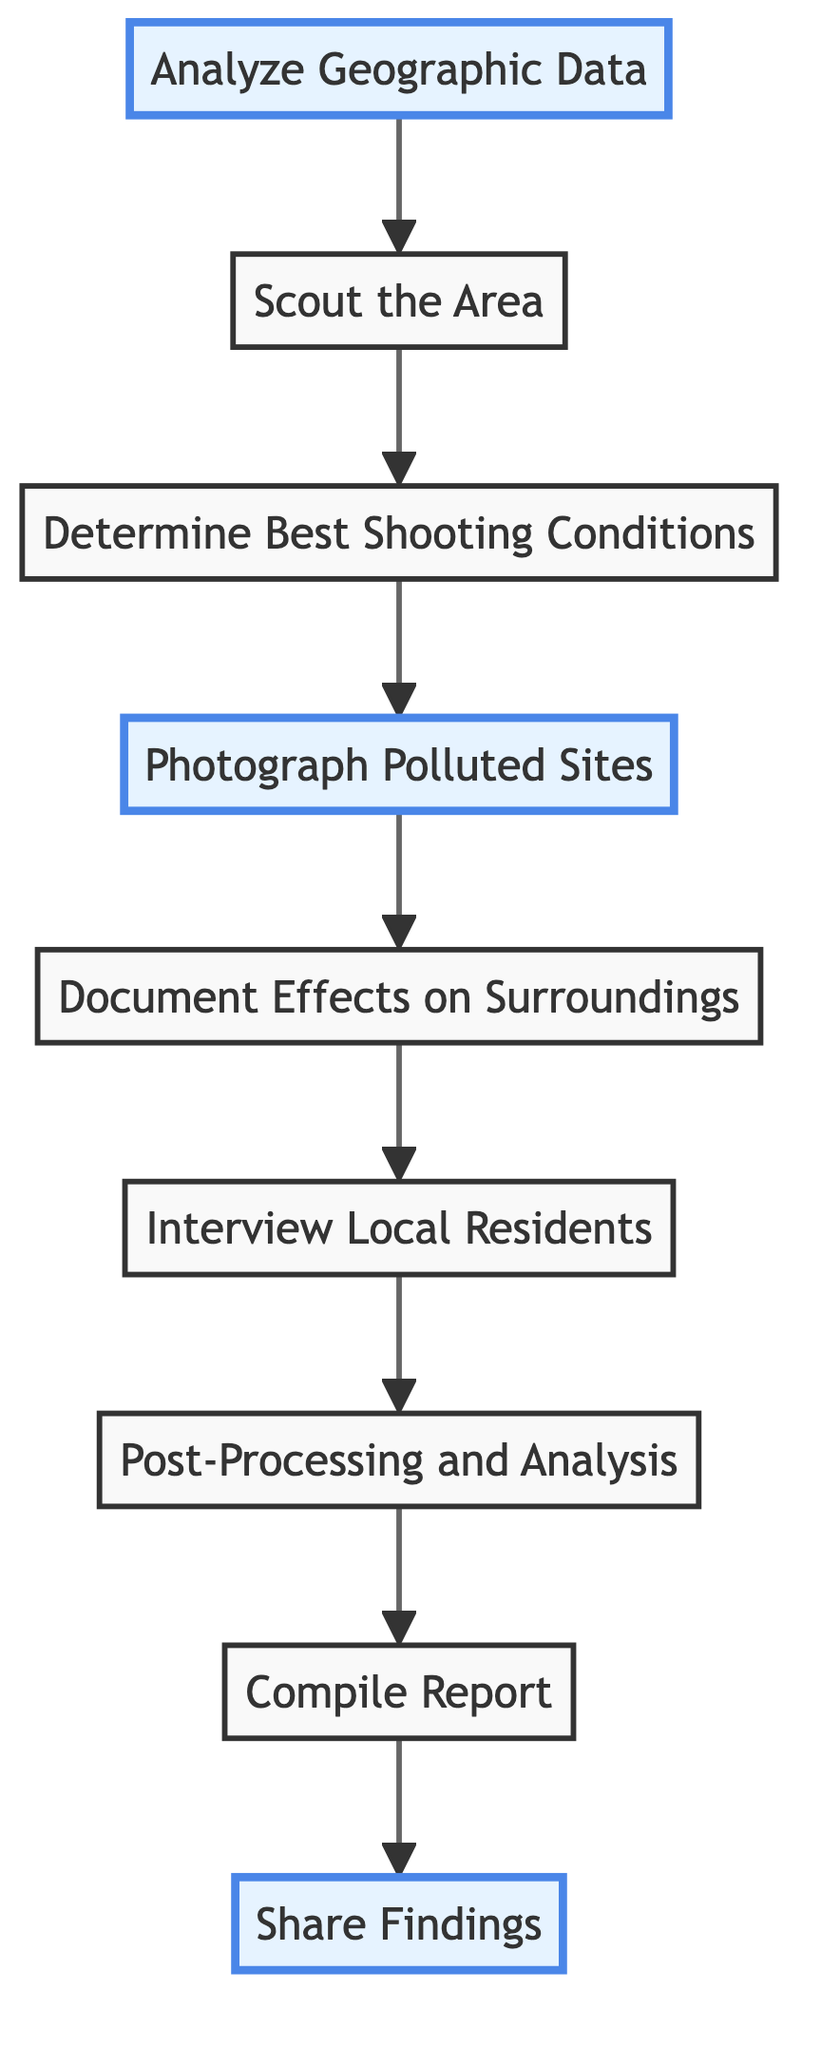What is the first stage in the process? The diagram indicates "Analyze Geographic Data" as the first stage, which is the starting point of the flow.
Answer: Analyze Geographic Data How many stages are there in the process? By counting each distinct stage in the diagram, I find a total of nine stages, which represent different steps from analysis to sharing findings.
Answer: 9 Which stage follows "Photograph Polluted Sites"? The stage directly connected after "Photograph Polluted Sites" is "Document Effects on Surroundings," indicating the next step in the process.
Answer: Document Effects on Surroundings What is the last stage in the process? The final stage in the flow chart is "Share Findings," indicating that after compiling a report, the results will be shared with the public.
Answer: Share Findings Is "Interview Local Residents" before or after "Determine Best Shooting Conditions"? Looking at the direction of the flow, "Interview Local Residents" comes after "Determine Best Shooting Conditions," as they are placed sequentially in the diagram.
Answer: After Which three stages are highlighted in the diagram? The diagram highlights "Analyze Geographic Data," "Photograph Polluted Sites," and "Share Findings," which are marked to emphasize their importance in the process.
Answer: Analyze Geographic Data, Photograph Polluted Sites, Share Findings What does the arrow from "Post-Processing and Analysis" point to? The arrow from "Post-Processing and Analysis" points to "Compile Report," indicating that the analysis phase leads directly to the compilation of the report.
Answer: Compile Report What is the main focus during the "Document Effects on Surroundings" stage? The main focus during this stage is on photographing the surrounding ecosystems influenced by river pollution, capturing the broader impacts beyond just the river.
Answer: Surrounding ecosystems What information source is mentioned in the "Analyze Geographic Data" stage? The "Analyze Geographic Data" stage mentions the Environmental Protection Agency (EPA) databases as a key source for identifying pollution issues.
Answer: Environmental Protection Agency (EPA) databases 